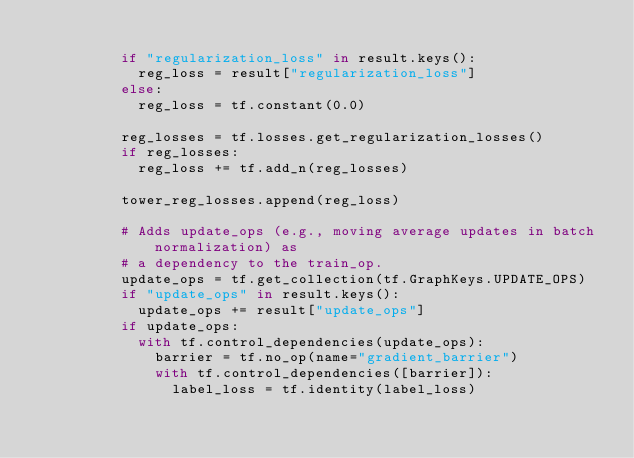Convert code to text. <code><loc_0><loc_0><loc_500><loc_500><_Python_>
          if "regularization_loss" in result.keys():
            reg_loss = result["regularization_loss"]
          else:
            reg_loss = tf.constant(0.0)

          reg_losses = tf.losses.get_regularization_losses()
          if reg_losses:
            reg_loss += tf.add_n(reg_losses)

          tower_reg_losses.append(reg_loss)

          # Adds update_ops (e.g., moving average updates in batch normalization) as
          # a dependency to the train_op.
          update_ops = tf.get_collection(tf.GraphKeys.UPDATE_OPS)
          if "update_ops" in result.keys():
            update_ops += result["update_ops"]
          if update_ops:
            with tf.control_dependencies(update_ops):
              barrier = tf.no_op(name="gradient_barrier")
              with tf.control_dependencies([barrier]):
                label_loss = tf.identity(label_loss)
</code> 